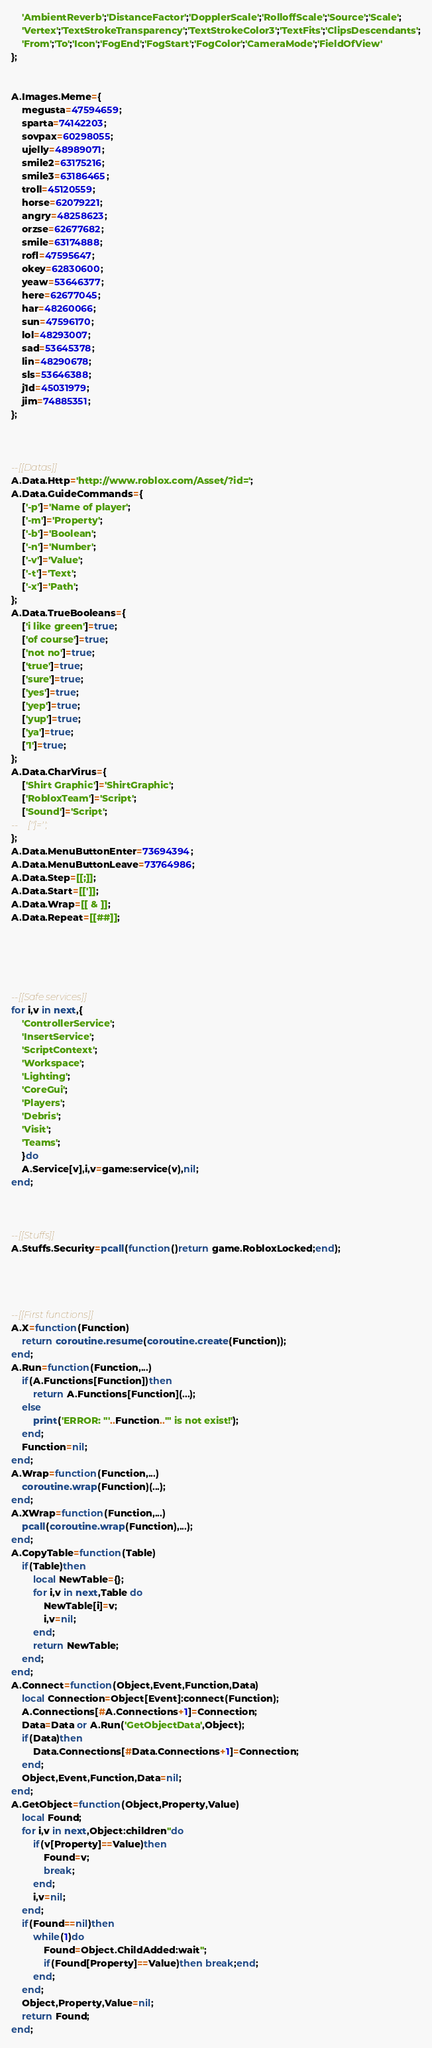Convert code to text. <code><loc_0><loc_0><loc_500><loc_500><_Lua_>    'AmbientReverb';'DistanceFactor';'DopplerScale';'RolloffScale';'Source';'Scale';
    'Vertex';'TextStrokeTransparency';'TextStrokeColor3';'TextFits';'ClipsDescendants';
    'From';'To';'Icon';'FogEnd';'FogStart';'FogColor';'CameraMode';'FieldOfView'
};


A.Images.Meme={
    megusta=47594659;
    sparta=74142203;
    sovpax=60298055;
    ujelly=48989071;
    smile2=63175216;
    smile3=63186465;
    troll=45120559;
    horse=62079221;
    angry=48258623;
    orzse=62677682;
    smile=63174888;
    rofl=47595647;
    okey=62830600;
    yeaw=53646377;
    here=62677045;
    har=48260066;
    sun=47596170;
    lol=48293007;
    sad=53645378;
    lin=48290678;
    sls=53646388;
    j1d=45031979;
    jim=74885351;
};



--[[Datas]]
A.Data.Http='http://www.roblox.com/Asset/?id=';
A.Data.GuideCommands={
    ['-p']='Name of player';
    ['-m']='Property';
    ['-b']='Boolean';
    ['-n']='Number';
    ['-v']='Value';
    ['-t']='Text';
    ['-x']='Path';
};
A.Data.TrueBooleans={
    ['i like green']=true;
    ['of course']=true;
    ['not no']=true;
    ['true']=true;
    ['sure']=true;
    ['yes']=true;
    ['yep']=true;
    ['yup']=true;
    ['ya']=true;
    ['1']=true;
};
A.Data.CharVirus={
    ['Shirt Graphic']='ShirtGraphic';
    ['RobloxTeam']='Script';
    ['Sound']='Script';
--    ['']='';
};
A.Data.MenuButtonEnter=73694394;
A.Data.MenuButtonLeave=73764986;
A.Data.Step=[[;]];
A.Data.Start=[[']];
A.Data.Wrap=[[ & ]];
A.Data.Repeat=[[##]];





--[[Safe services]]
for i,v in next,{
    'ControllerService';
    'InsertService';
    'ScriptContext';
    'Workspace';
    'Lighting';
    'CoreGui';
    'Players';
    'Debris';
    'Visit';
    'Teams';
    }do
    A.Service[v],i,v=game:service(v),nil;
end;



--[[Stuffs]]
A.Stuffs.Security=pcall(function()return game.RobloxLocked;end);




--[[First functions]]
A.X=function(Function)
    return coroutine.resume(coroutine.create(Function));
end;
A.Run=function(Function,...)
    if(A.Functions[Function])then
        return A.Functions[Function](...);
    else
        print('ERROR: "'..Function..'" is not exist!');
    end;
    Function=nil;
end;
A.Wrap=function(Function,...)
    coroutine.wrap(Function)(...);
end;
A.XWrap=function(Function,...)
    pcall(coroutine.wrap(Function),...);
end;
A.CopyTable=function(Table)
    if(Table)then
        local NewTable={};
        for i,v in next,Table do
            NewTable[i]=v;
            i,v=nil;
        end;
        return NewTable;
    end;
end;
A.Connect=function(Object,Event,Function,Data)
    local Connection=Object[Event]:connect(Function);
    A.Connections[#A.Connections+1]=Connection;
    Data=Data or A.Run('GetObjectData',Object);
    if(Data)then
        Data.Connections[#Data.Connections+1]=Connection;
    end;
    Object,Event,Function,Data=nil;
end;
A.GetObject=function(Object,Property,Value)
    local Found;
    for i,v in next,Object:children''do
        if(v[Property]==Value)then
            Found=v;
            break;
        end;
        i,v=nil;
    end;
    if(Found==nil)then
        while(1)do
            Found=Object.ChildAdded:wait'';
            if(Found[Property]==Value)then break;end;
        end;
    end;
    Object,Property,Value=nil;
    return Found;
end;</code> 